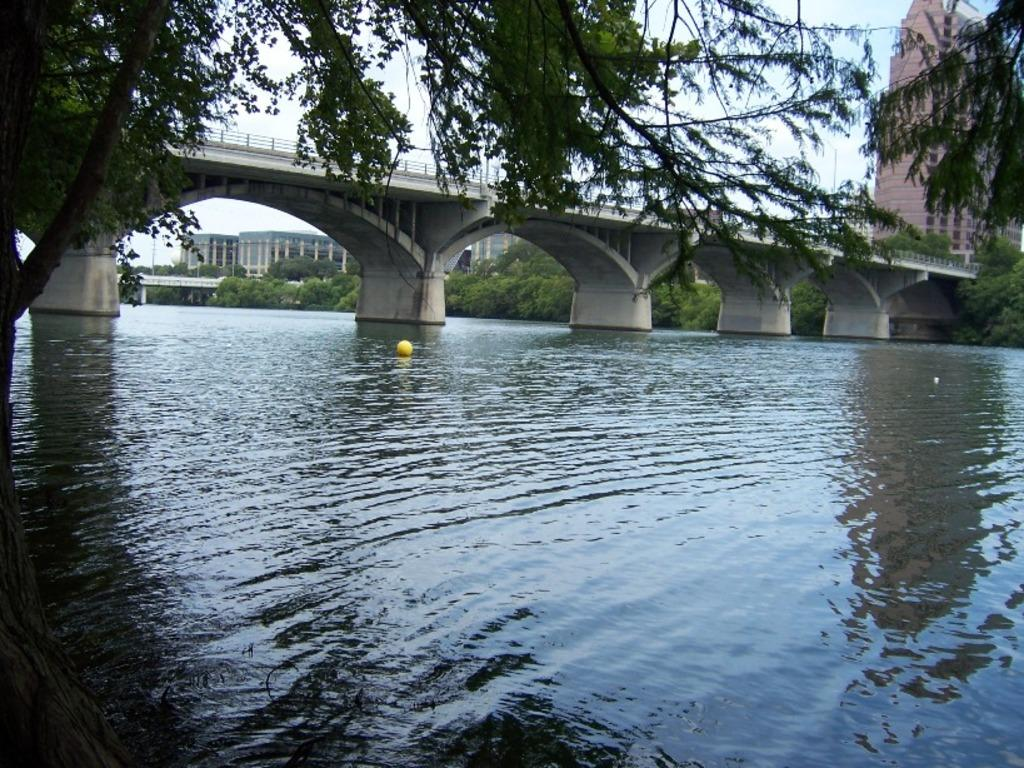What type of structure can be seen in the image? There is a bridge in the image. What natural element is visible in the image? There is water visible in the image. What type of vegetation is present in the image? There are trees in the image. What type of man-made structures can be seen in the image? There are buildings in the image. What is visible at the top of the image? The sky is visible at the top of the image. Can you see any wounds on the bridge in the image? There are no wounds present in the image; it is a picture of a bridge, water, trees, buildings, and the sky. What type of fowl is swimming in the water under the bridge? There is no fowl present in the image; it only shows a bridge, water, trees, buildings, and the sky. 